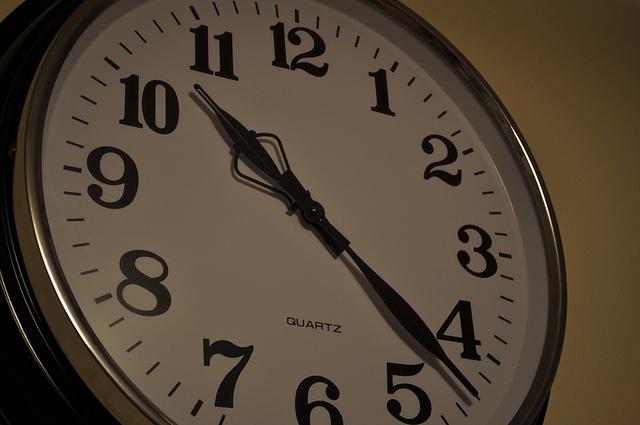Is there a second hand in the picture?
Write a very short answer. Yes. What is the backgrounds two colors?
Write a very short answer. Black and white. Is this a mechanical clock?
Give a very brief answer. Yes. What time is it?
Keep it brief. 10:23. What number is shown on the watch next FRI?
Keep it brief. 10:22. What country is this scene in?
Write a very short answer. Usa. What kind of numbers are on the clock?
Keep it brief. Black ones. What does the writing on the clock say?
Be succinct. Quartz. What is the time on the clock?
Give a very brief answer. 10:22. What time will it be in thirty minutes?
Write a very short answer. 10:52. What time does the clock say?
Short answer required. 10:22. 